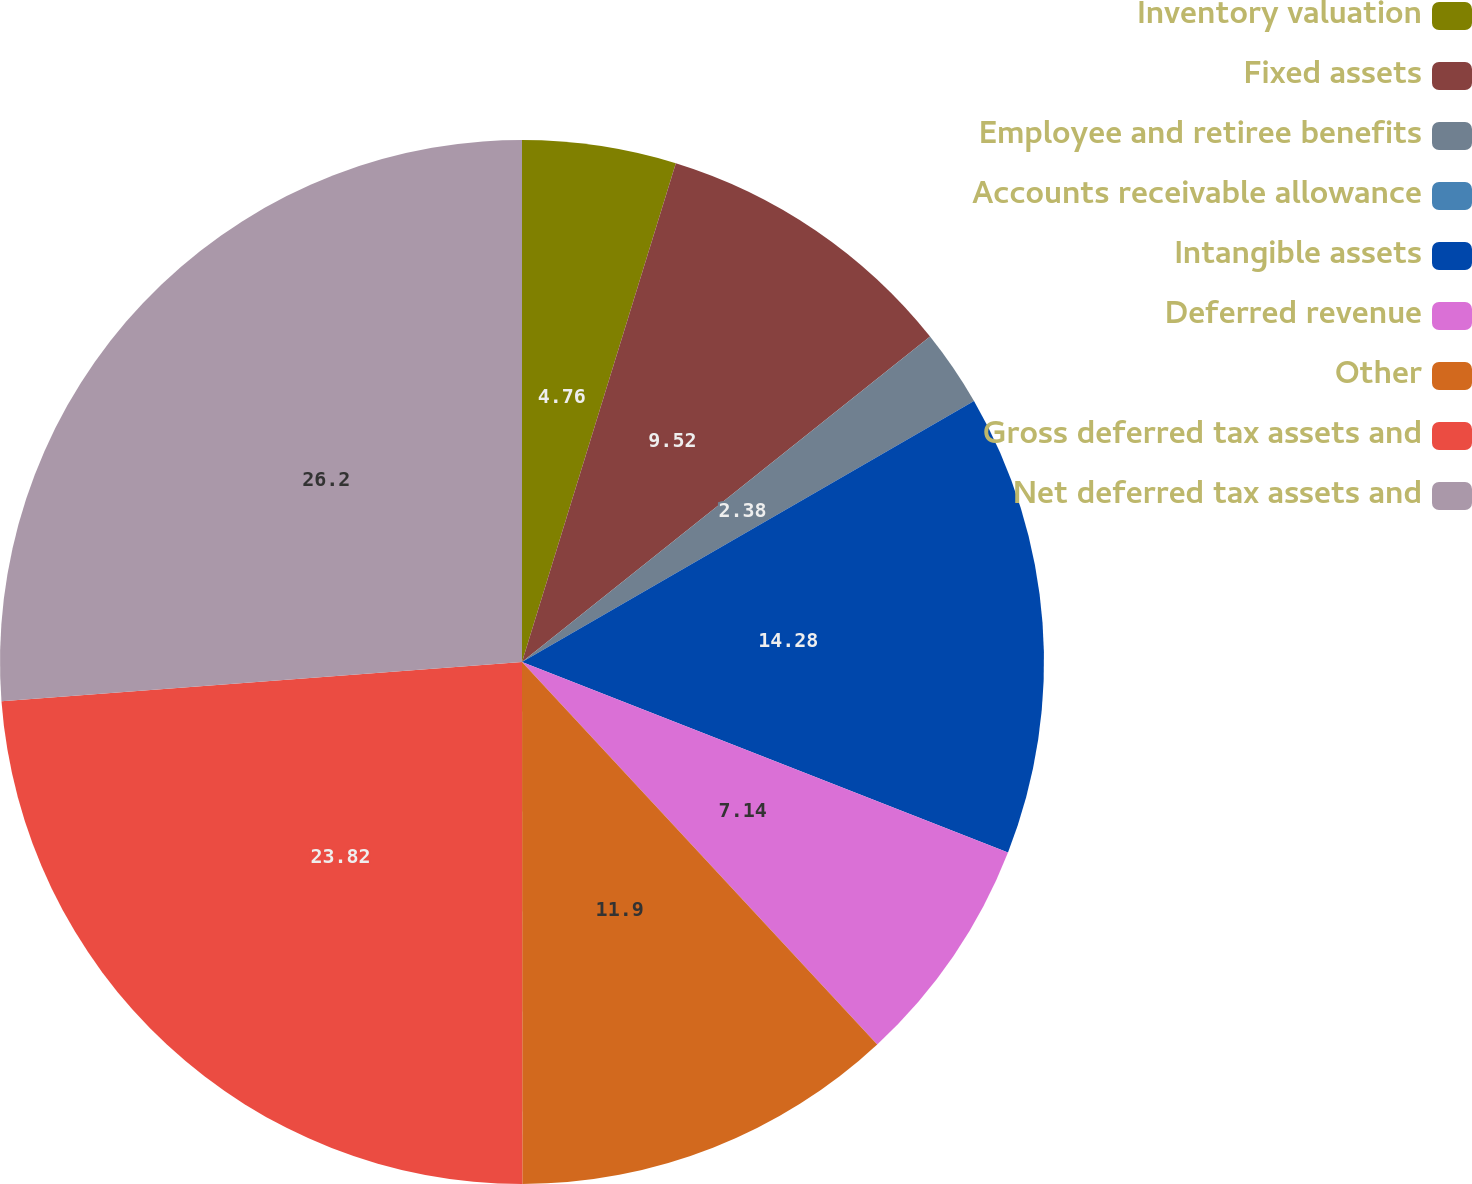<chart> <loc_0><loc_0><loc_500><loc_500><pie_chart><fcel>Inventory valuation<fcel>Fixed assets<fcel>Employee and retiree benefits<fcel>Accounts receivable allowance<fcel>Intangible assets<fcel>Deferred revenue<fcel>Other<fcel>Gross deferred tax assets and<fcel>Net deferred tax assets and<nl><fcel>4.76%<fcel>9.52%<fcel>2.38%<fcel>0.0%<fcel>14.28%<fcel>7.14%<fcel>11.9%<fcel>23.81%<fcel>26.19%<nl></chart> 